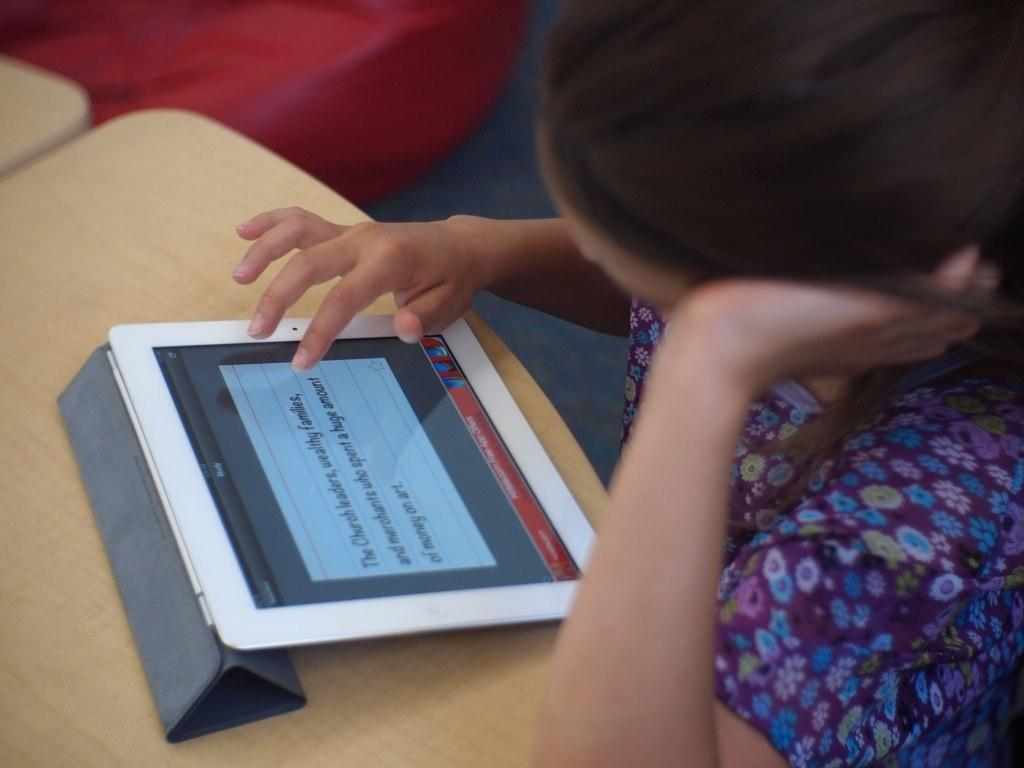Who is present in the image? There are girls in the image. What are the girls doing in the image? The girls are sitting at a table. What object can be seen on the table in the image? There is a tablet on the table. What advertisement can be seen on the tablet in the image? There is no advertisement visible on the tablet in the image. How many sisters are present in the image? The provided facts do not mention any information about the relationship between the girls, so we cannot determine if they are sisters. 